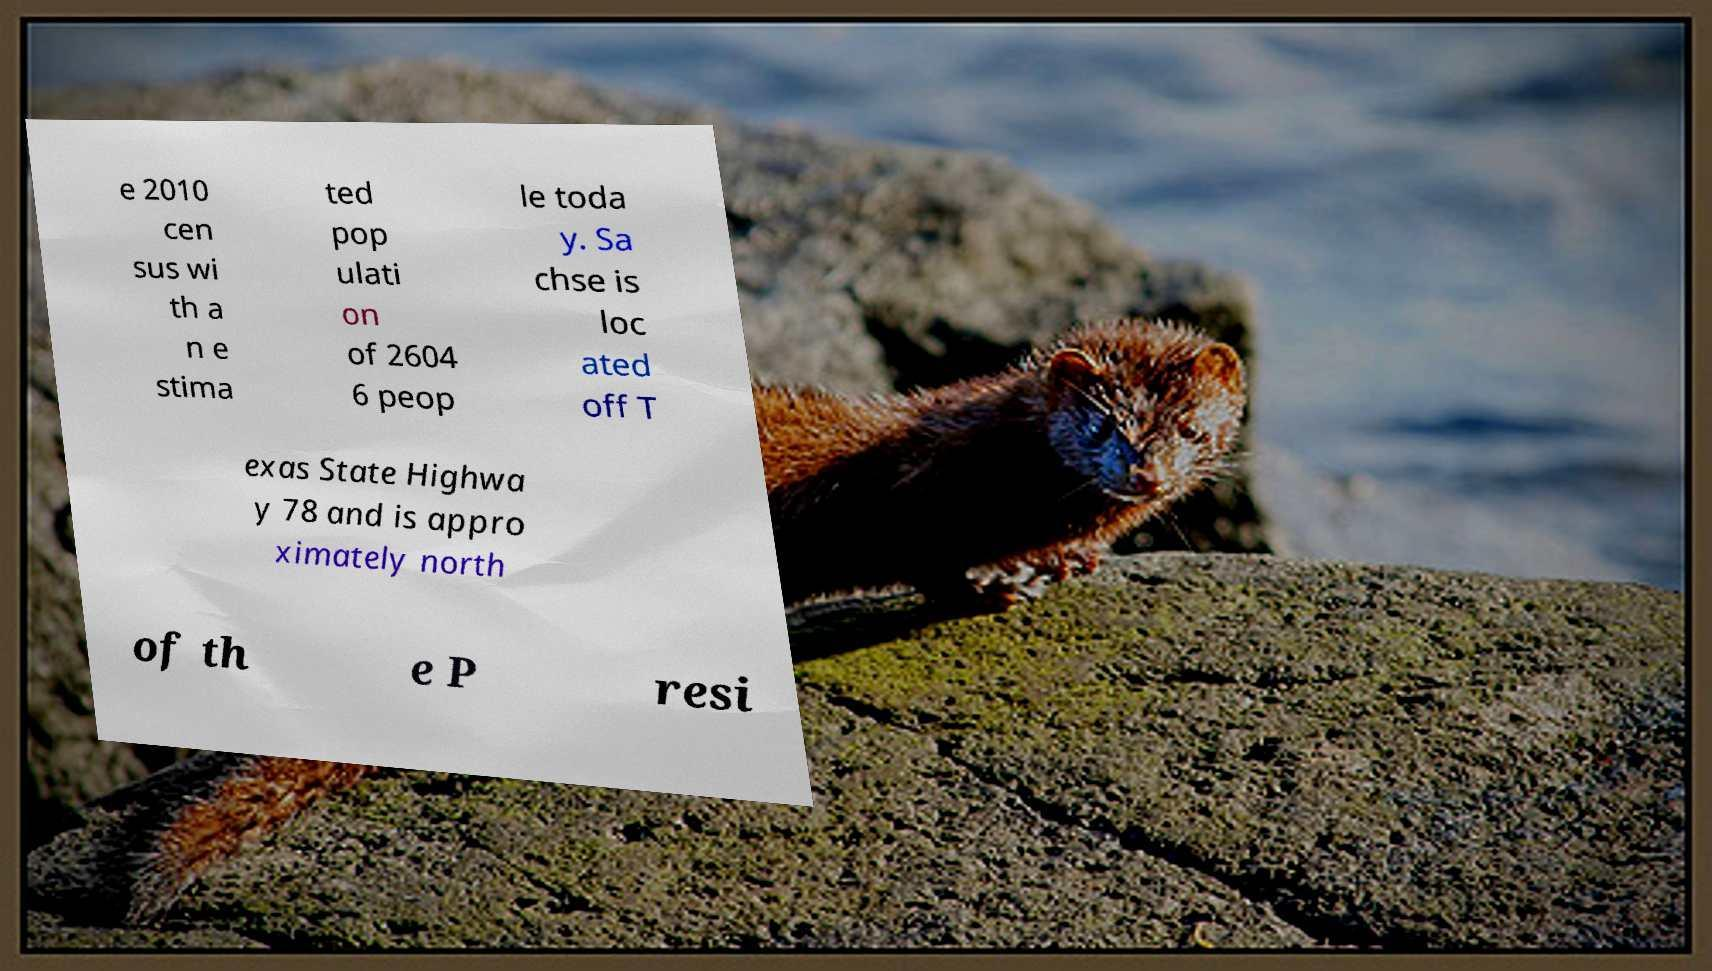Could you assist in decoding the text presented in this image and type it out clearly? e 2010 cen sus wi th a n e stima ted pop ulati on of 2604 6 peop le toda y. Sa chse is loc ated off T exas State Highwa y 78 and is appro ximately north of th e P resi 